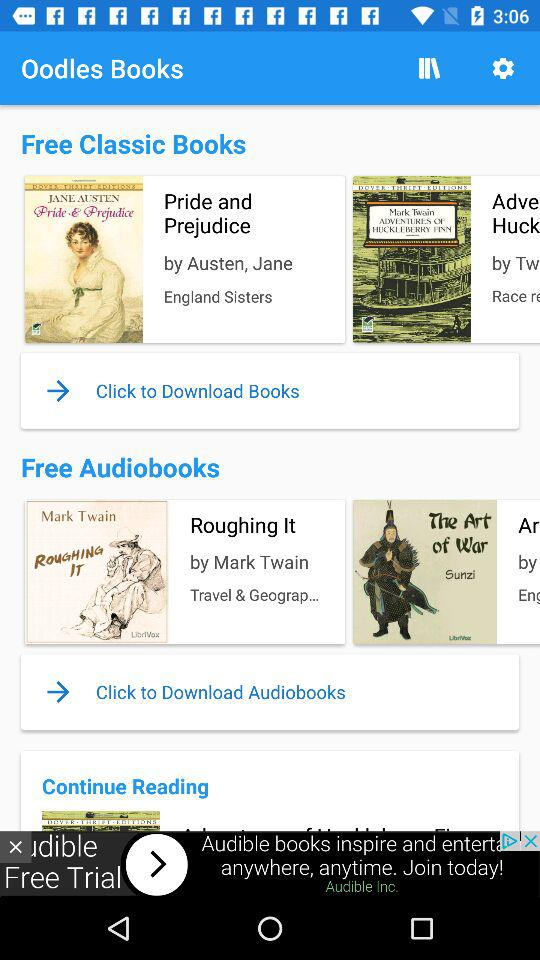What category is the book "Roughing It" in? The book "Roughing It" is in the category "Travel & Geograp...". 